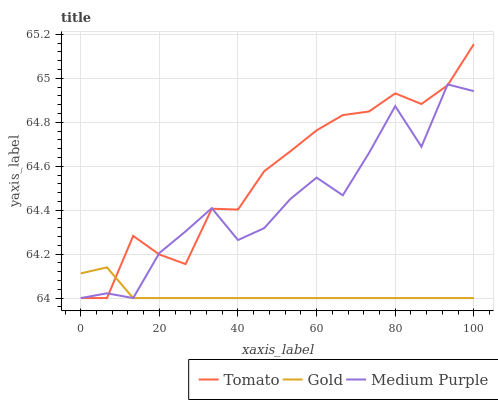Does Gold have the minimum area under the curve?
Answer yes or no. Yes. Does Tomato have the maximum area under the curve?
Answer yes or no. Yes. Does Medium Purple have the minimum area under the curve?
Answer yes or no. No. Does Medium Purple have the maximum area under the curve?
Answer yes or no. No. Is Gold the smoothest?
Answer yes or no. Yes. Is Medium Purple the roughest?
Answer yes or no. Yes. Is Medium Purple the smoothest?
Answer yes or no. No. Is Gold the roughest?
Answer yes or no. No. Does Tomato have the lowest value?
Answer yes or no. Yes. Does Tomato have the highest value?
Answer yes or no. Yes. Does Medium Purple have the highest value?
Answer yes or no. No. Does Medium Purple intersect Tomato?
Answer yes or no. Yes. Is Medium Purple less than Tomato?
Answer yes or no. No. Is Medium Purple greater than Tomato?
Answer yes or no. No. 